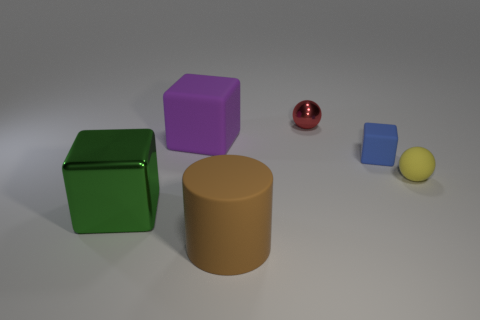Subtract all gray blocks. Subtract all red cylinders. How many blocks are left? 3 Add 2 gray metal objects. How many objects exist? 8 Subtract all cylinders. How many objects are left? 5 Add 6 shiny cubes. How many shiny cubes exist? 7 Subtract 0 brown cubes. How many objects are left? 6 Subtract all red metal spheres. Subtract all big green metallic things. How many objects are left? 4 Add 1 large brown things. How many large brown things are left? 2 